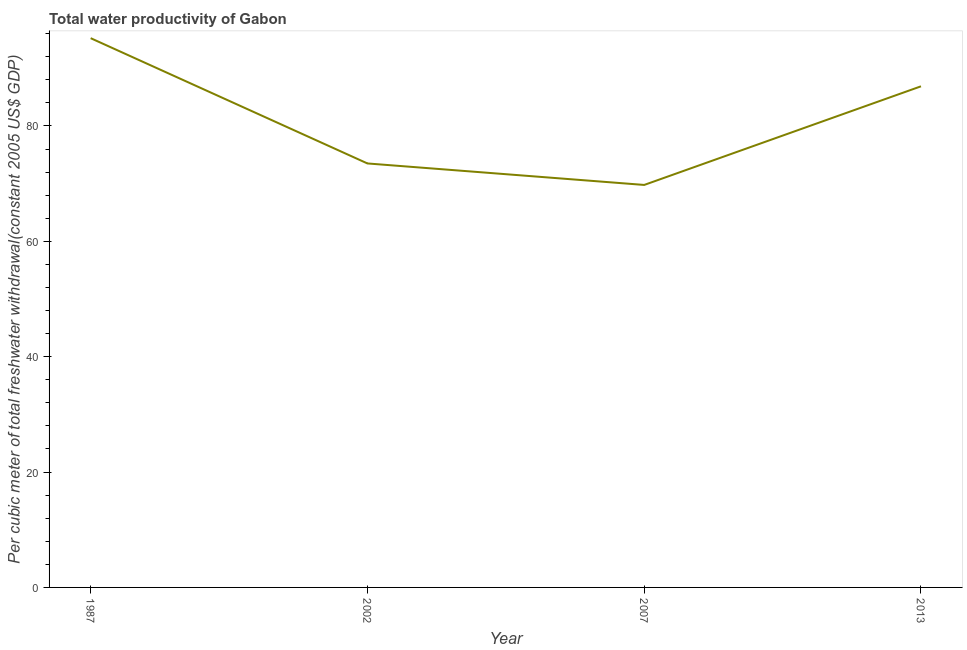What is the total water productivity in 2013?
Keep it short and to the point. 86.88. Across all years, what is the maximum total water productivity?
Make the answer very short. 95.23. Across all years, what is the minimum total water productivity?
Offer a very short reply. 69.78. In which year was the total water productivity minimum?
Your answer should be compact. 2007. What is the sum of the total water productivity?
Give a very brief answer. 325.39. What is the difference between the total water productivity in 2002 and 2013?
Keep it short and to the point. -13.37. What is the average total water productivity per year?
Ensure brevity in your answer.  81.35. What is the median total water productivity?
Your response must be concise. 80.19. Do a majority of the years between 2013 and 2002 (inclusive) have total water productivity greater than 28 US$?
Provide a short and direct response. No. What is the ratio of the total water productivity in 2002 to that in 2013?
Offer a very short reply. 0.85. Is the difference between the total water productivity in 1987 and 2013 greater than the difference between any two years?
Offer a very short reply. No. What is the difference between the highest and the second highest total water productivity?
Offer a terse response. 8.35. Is the sum of the total water productivity in 1987 and 2002 greater than the maximum total water productivity across all years?
Your answer should be compact. Yes. What is the difference between the highest and the lowest total water productivity?
Your response must be concise. 25.45. In how many years, is the total water productivity greater than the average total water productivity taken over all years?
Provide a short and direct response. 2. How many lines are there?
Provide a short and direct response. 1. How many years are there in the graph?
Keep it short and to the point. 4. What is the difference between two consecutive major ticks on the Y-axis?
Your answer should be very brief. 20. Are the values on the major ticks of Y-axis written in scientific E-notation?
Provide a short and direct response. No. Does the graph contain grids?
Offer a terse response. No. What is the title of the graph?
Your answer should be very brief. Total water productivity of Gabon. What is the label or title of the Y-axis?
Offer a terse response. Per cubic meter of total freshwater withdrawal(constant 2005 US$ GDP). What is the Per cubic meter of total freshwater withdrawal(constant 2005 US$ GDP) of 1987?
Your answer should be very brief. 95.23. What is the Per cubic meter of total freshwater withdrawal(constant 2005 US$ GDP) of 2002?
Offer a very short reply. 73.51. What is the Per cubic meter of total freshwater withdrawal(constant 2005 US$ GDP) of 2007?
Offer a terse response. 69.78. What is the Per cubic meter of total freshwater withdrawal(constant 2005 US$ GDP) of 2013?
Give a very brief answer. 86.88. What is the difference between the Per cubic meter of total freshwater withdrawal(constant 2005 US$ GDP) in 1987 and 2002?
Provide a succinct answer. 21.72. What is the difference between the Per cubic meter of total freshwater withdrawal(constant 2005 US$ GDP) in 1987 and 2007?
Make the answer very short. 25.45. What is the difference between the Per cubic meter of total freshwater withdrawal(constant 2005 US$ GDP) in 1987 and 2013?
Give a very brief answer. 8.35. What is the difference between the Per cubic meter of total freshwater withdrawal(constant 2005 US$ GDP) in 2002 and 2007?
Make the answer very short. 3.73. What is the difference between the Per cubic meter of total freshwater withdrawal(constant 2005 US$ GDP) in 2002 and 2013?
Offer a terse response. -13.37. What is the difference between the Per cubic meter of total freshwater withdrawal(constant 2005 US$ GDP) in 2007 and 2013?
Ensure brevity in your answer.  -17.1. What is the ratio of the Per cubic meter of total freshwater withdrawal(constant 2005 US$ GDP) in 1987 to that in 2002?
Offer a very short reply. 1.29. What is the ratio of the Per cubic meter of total freshwater withdrawal(constant 2005 US$ GDP) in 1987 to that in 2007?
Offer a terse response. 1.36. What is the ratio of the Per cubic meter of total freshwater withdrawal(constant 2005 US$ GDP) in 1987 to that in 2013?
Offer a very short reply. 1.1. What is the ratio of the Per cubic meter of total freshwater withdrawal(constant 2005 US$ GDP) in 2002 to that in 2007?
Ensure brevity in your answer.  1.05. What is the ratio of the Per cubic meter of total freshwater withdrawal(constant 2005 US$ GDP) in 2002 to that in 2013?
Provide a succinct answer. 0.85. What is the ratio of the Per cubic meter of total freshwater withdrawal(constant 2005 US$ GDP) in 2007 to that in 2013?
Make the answer very short. 0.8. 